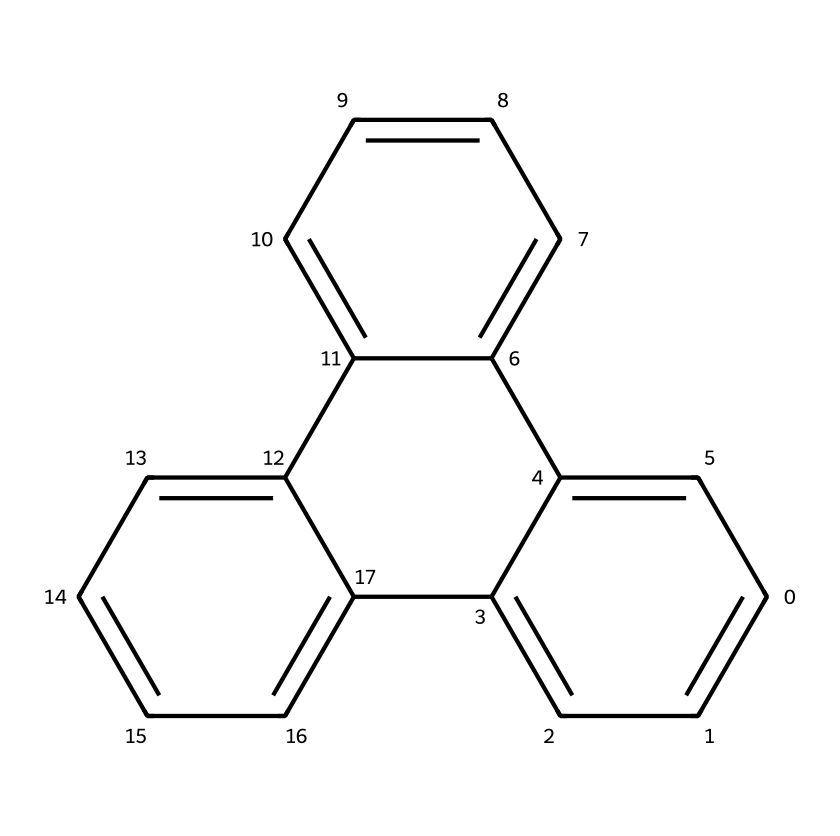What is the main structure type of this compound? The displayed SMILES represents a polycyclic aromatic hydrocarbon (PAH), which is evident from the presence of multiple interconnected benzene rings.
Answer: polycyclic aromatic hydrocarbon How many carbon atoms are in this structure? Counting each individual carbon atom within the rings represented in the SMILES shows a total of 15 carbon atoms.
Answer: 15 Is the structure planar or non-planar? Due to the arrangement of carbon atoms in a two-dimensional plane formed by the fused rings, the structure is planar.
Answer: planar What is the potential application area of graphene quantum dots? Given the properties of graphene quantum dots, they are primarily researched for use in solar cells among other applications since they enhance light absorption.
Answer: solar cells How does the size of the quantum dots influence their optical properties? The optical properties of quantum dots, including their absorption and emission spectra, are size-dependent; as the size decreases, the energy gap increases, shifting the color of emitted light.
Answer: size-dependent What is one key advantage of using graphene quantum dots in photovoltaic devices? Graphene quantum dots have high electron mobility, which enhances charge transport efficiency in solar cells, making them a valuable material.
Answer: high electron mobility 